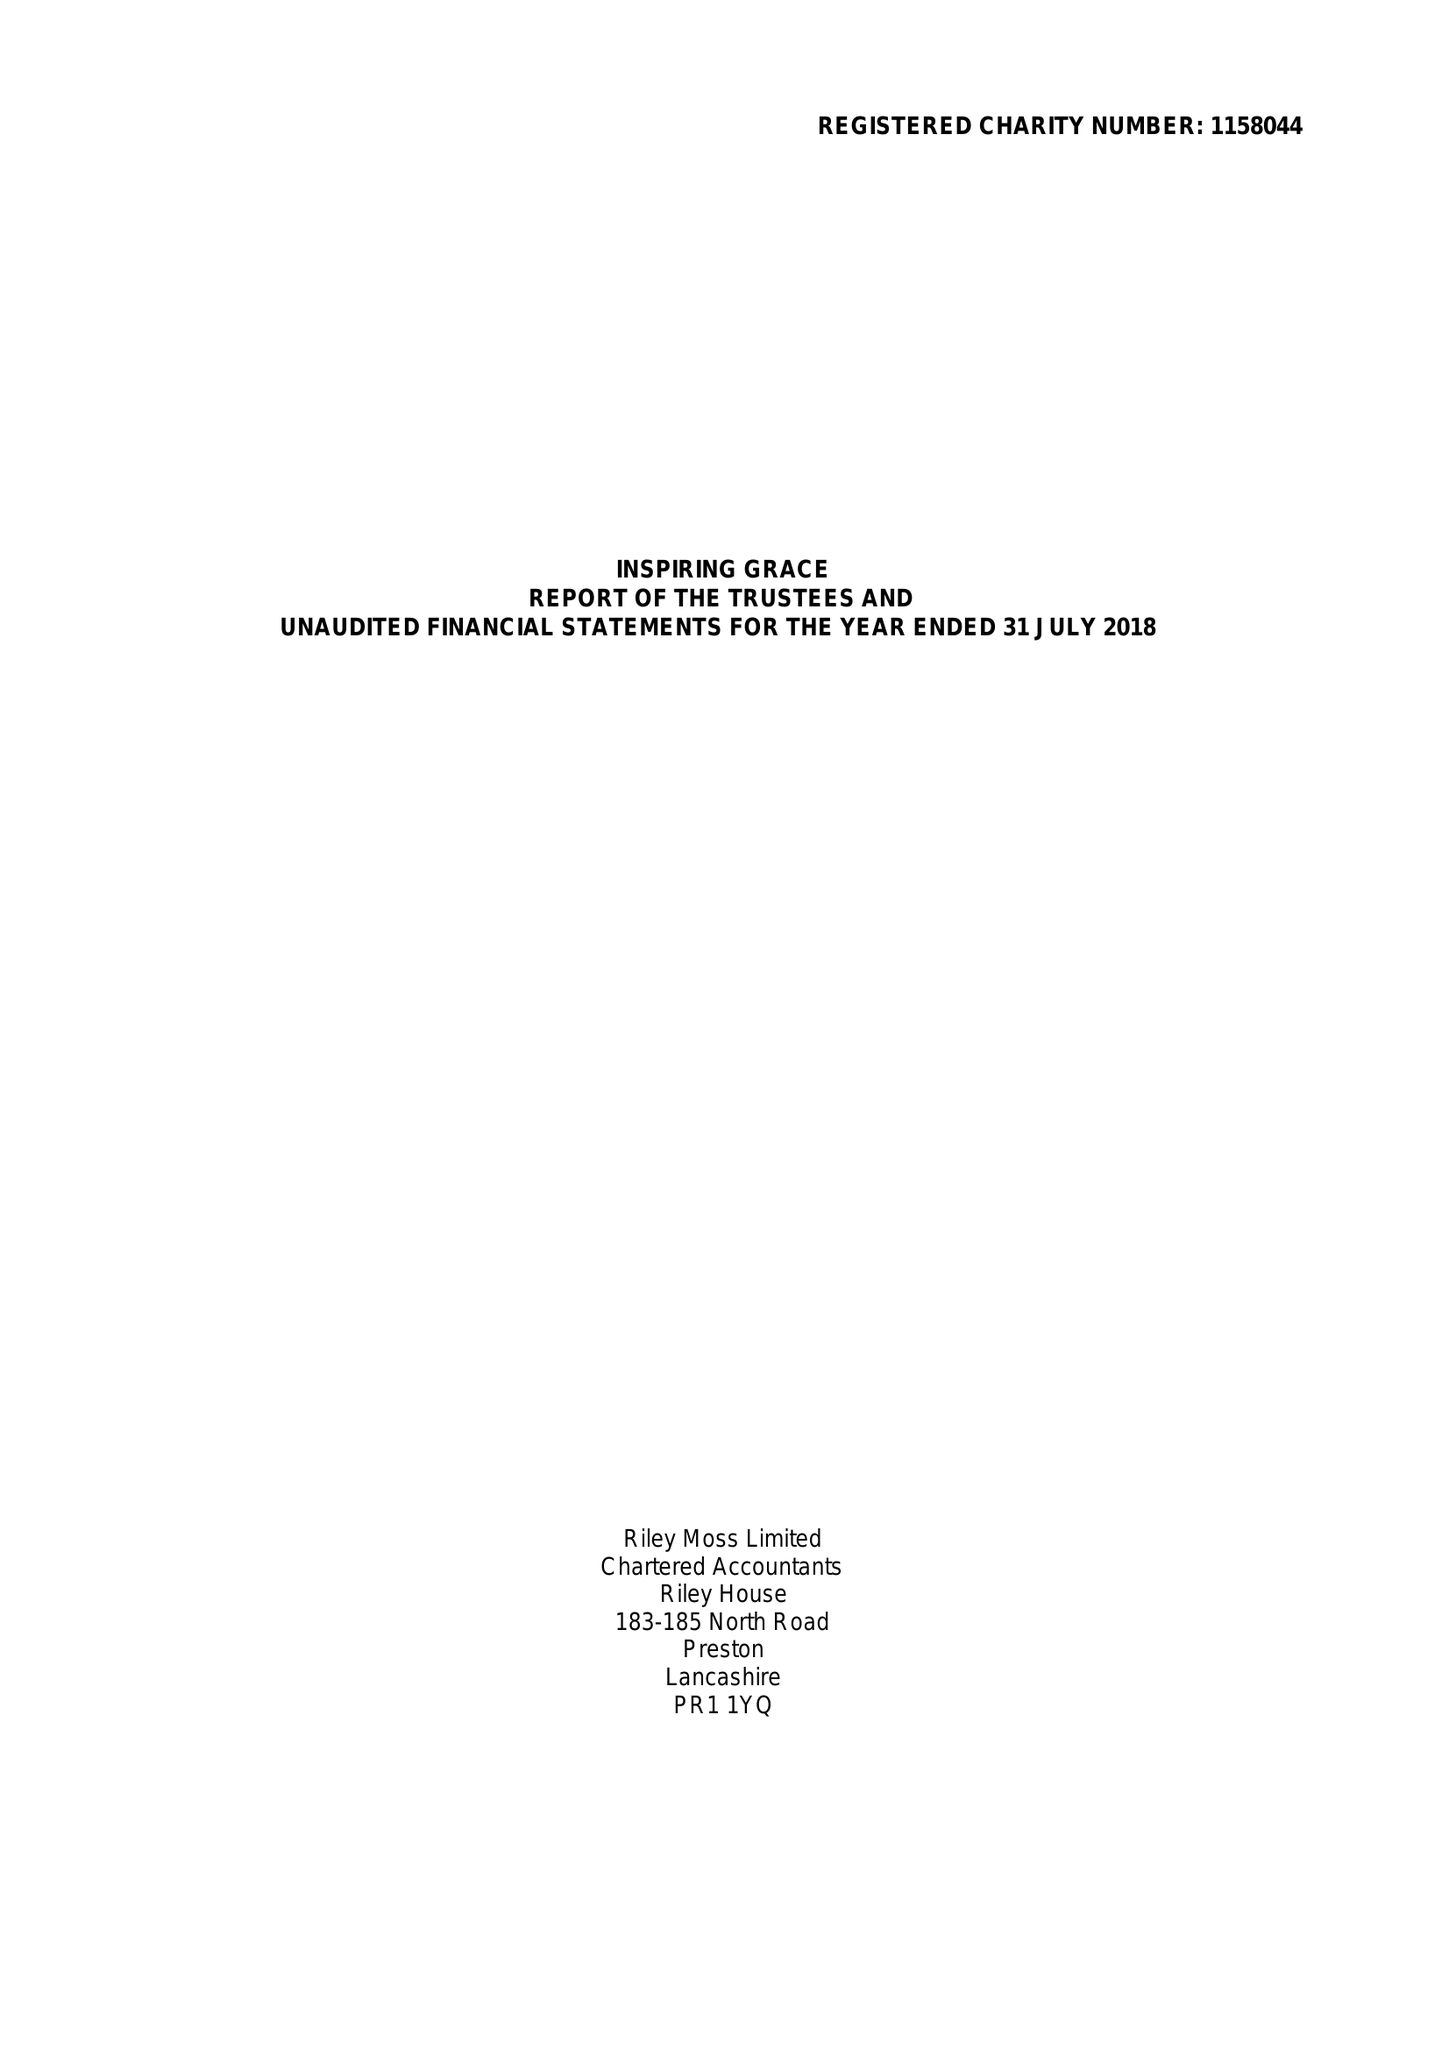What is the value for the address__street_line?
Answer the question using a single word or phrase. 22 EDWARD STREET 